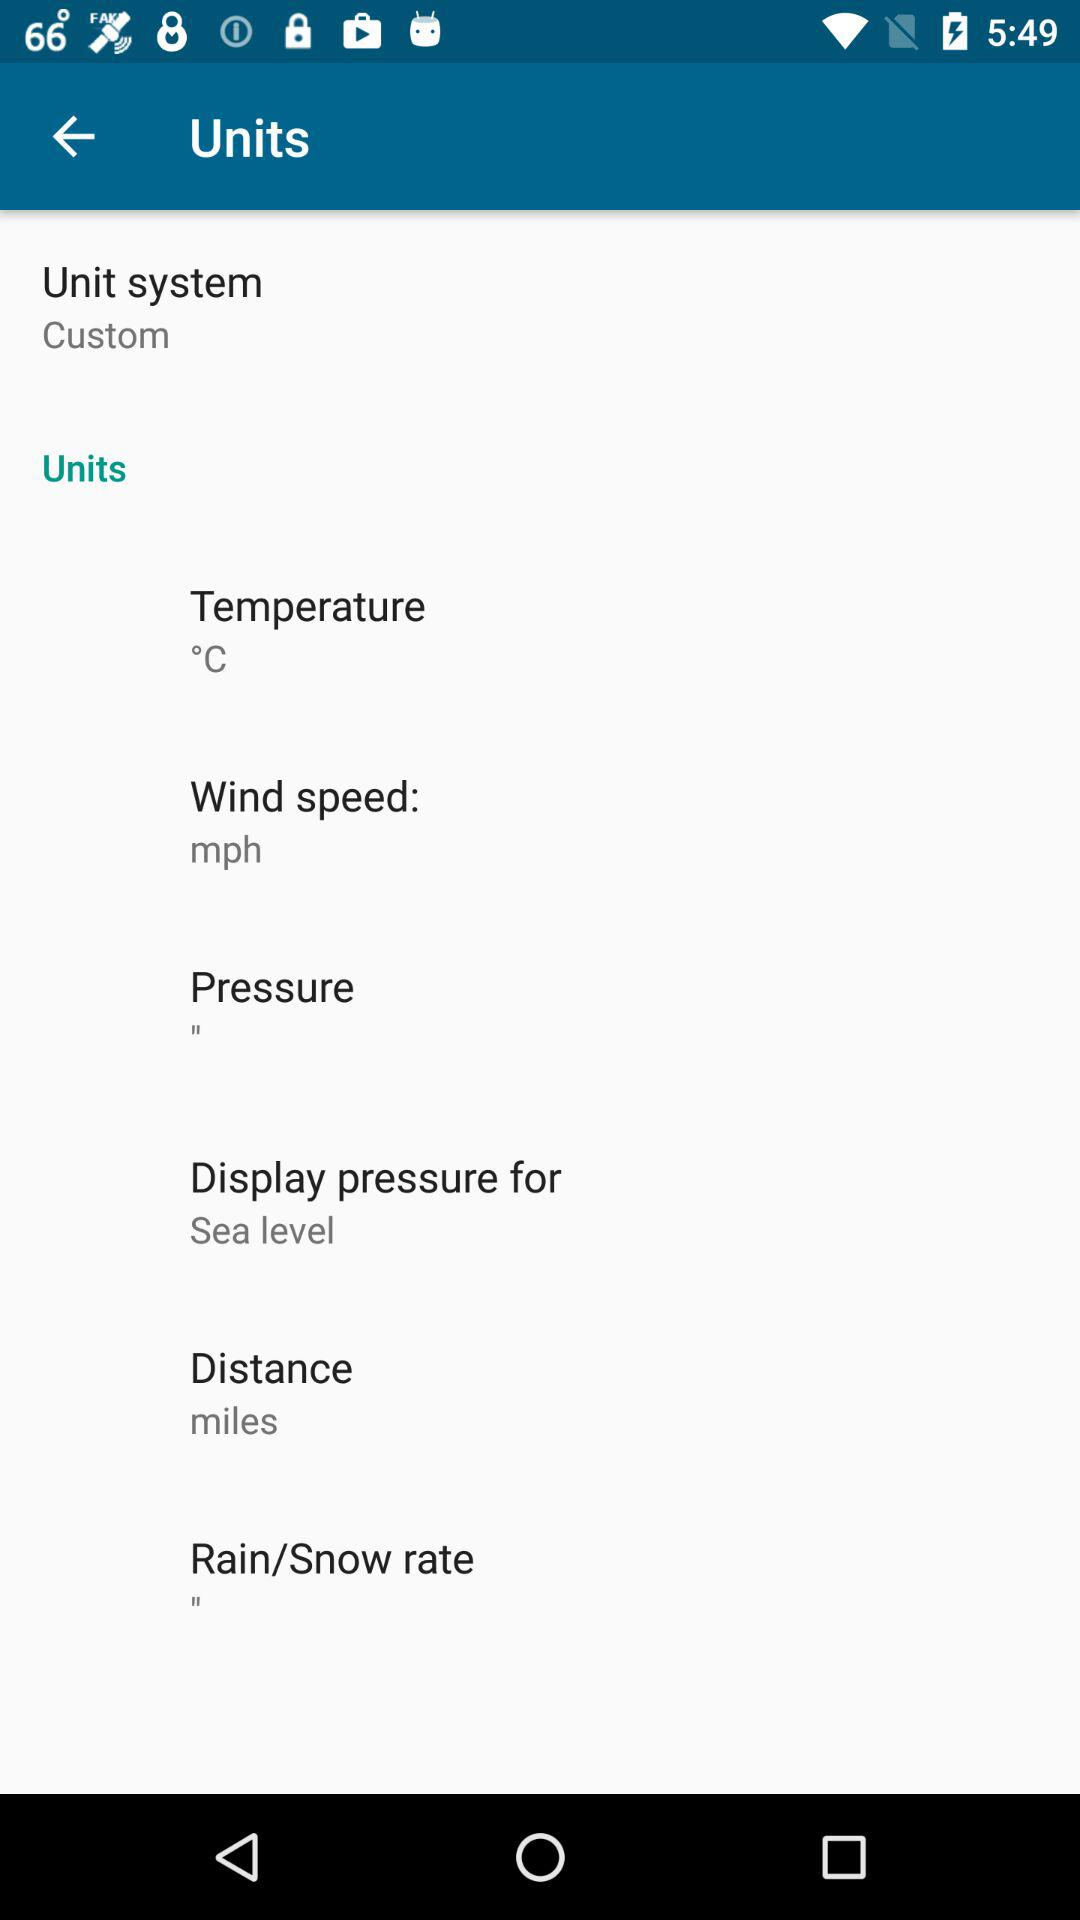What's the wind speed? The wind speed is mph. 